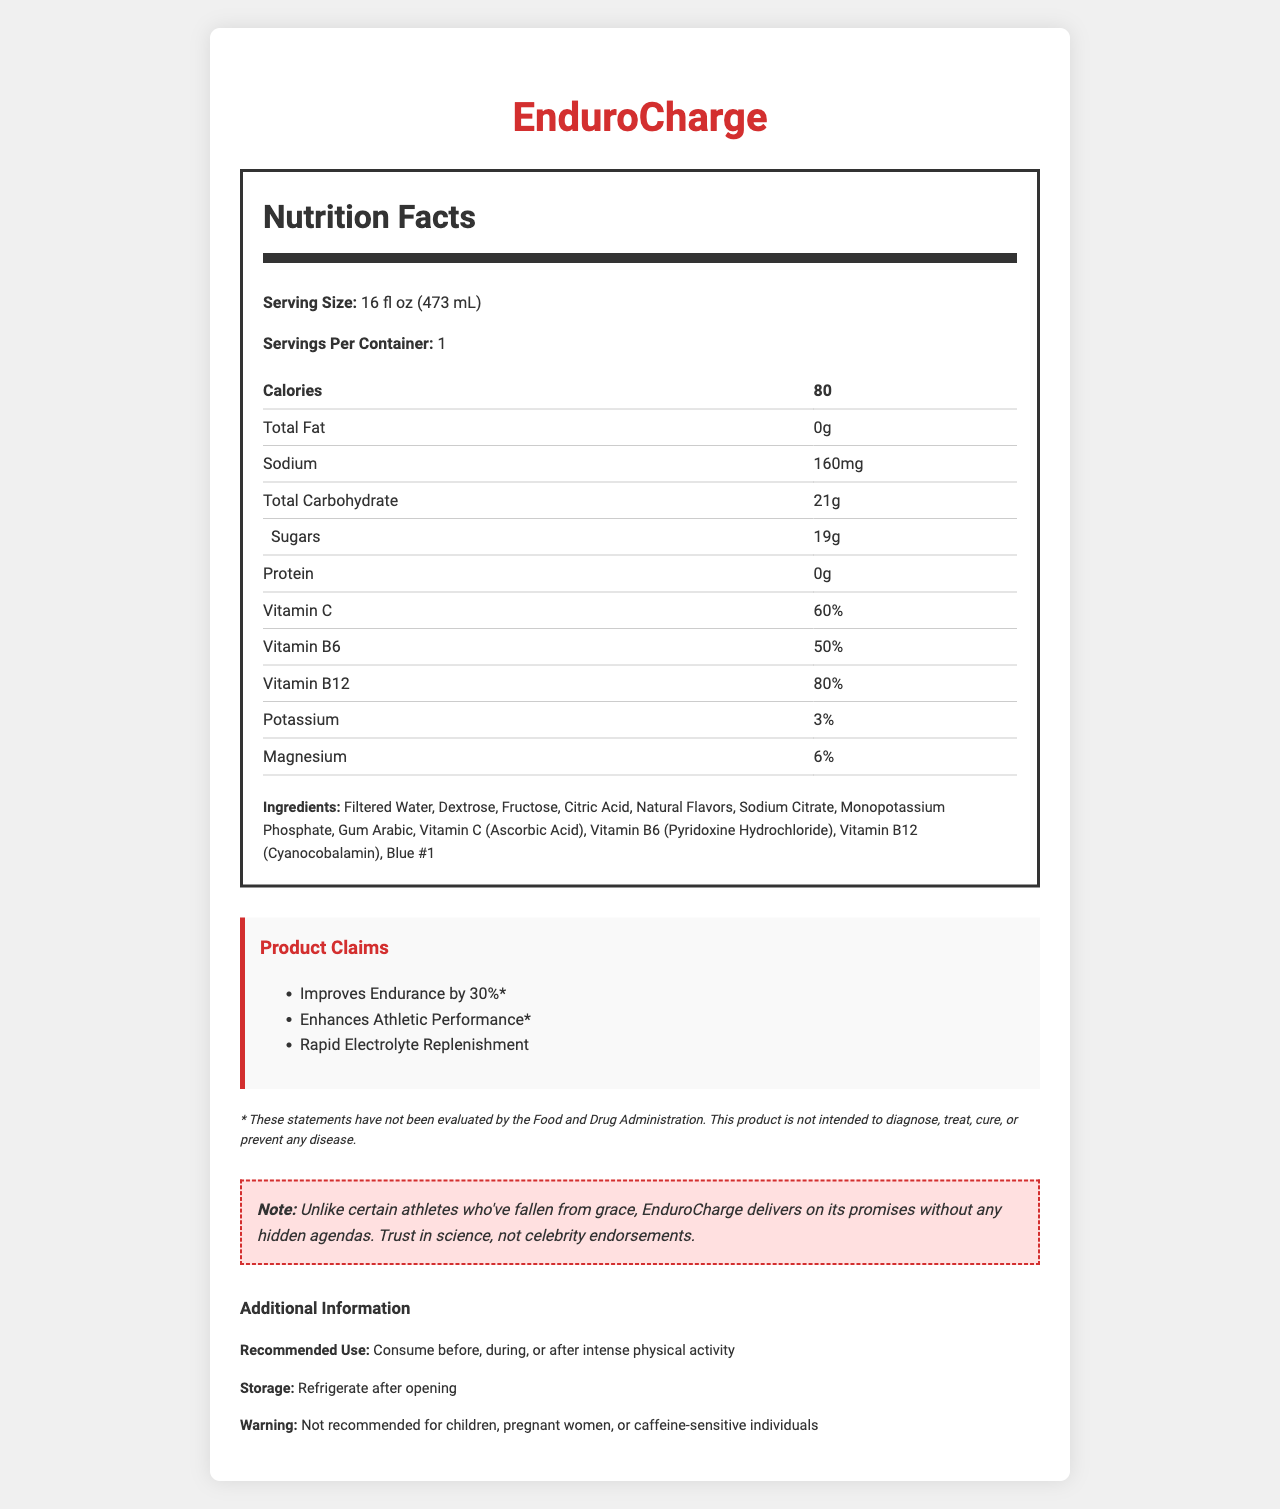what is the serving size of EnduroCharge? The serving size is explicitly mentioned in the document as "16 fl oz (473 mL)."
Answer: 16 fl oz (473 mL) how many calories are in one serving of EnduroCharge? The document lists the calories for one serving as 80.
Answer: 80 what is the amount of sodium in EnduroCharge? The sodium content listed in the nutritional information is 160mg.
Answer: 160mg what percentage of Vitamin C does EnduroCharge provide? The document states that EnduroCharge provides 60% of the daily value of Vitamin C.
Answer: 60% list two vitamins found in EnduroCharge The document lists both Vitamin B6 and Vitamin B12 in the nutritional information.
Answer: Vitamin B6 and Vitamin B12 how many grams of total carbohydrate are there in EnduroCharge? The nutritional information indicates that there are 21 grams of total carbohydrates.
Answer: 21g which ingredient listed is a coloring agent? A. Fructose B. Gum Arabic C. Blue #1 D. Sodium Citrate Blue #1 is a coloring agent, which can be inferred from the typical function of such ingredients in food products.
Answer: C. Blue #1 what are the marketing claims made by EnduroCharge? A. Improves Endurance by 30% B. Supports Heart Health C. Enhances Athletic Performance D. Contains Probiotics The marketing claims mentioned include "Improves Endurance by 30%" and "Enhances Athletic Performance."
Answer: A and C is EnduroCharge intended for use by children? The warning states that the product is not recommended for children, along with pregnant women or caffeine-sensitive individuals.
Answer: No describe the main point of the document The document outlines the nutritional facts, ingredients, and benefits of the sports drink, EnduroCharge. It also includes marketing claims, a disclaimer, and usage recommendations.
Answer: EnduroCharge is a sports drink designed to improve athletic performance and endurance. It contains various vitamins and electrolytes, with claims of enhancing endurance by 30%. The document details its nutritional content, ingredients, and provides specific usage recommendations and warnings. does the document contain enough information to verify the marketing claims? The disclaimer states that the marketing claims have not been evaluated by the Food and Drug Administration, indicating that there is no verification provided for the claims.
Answer: No 